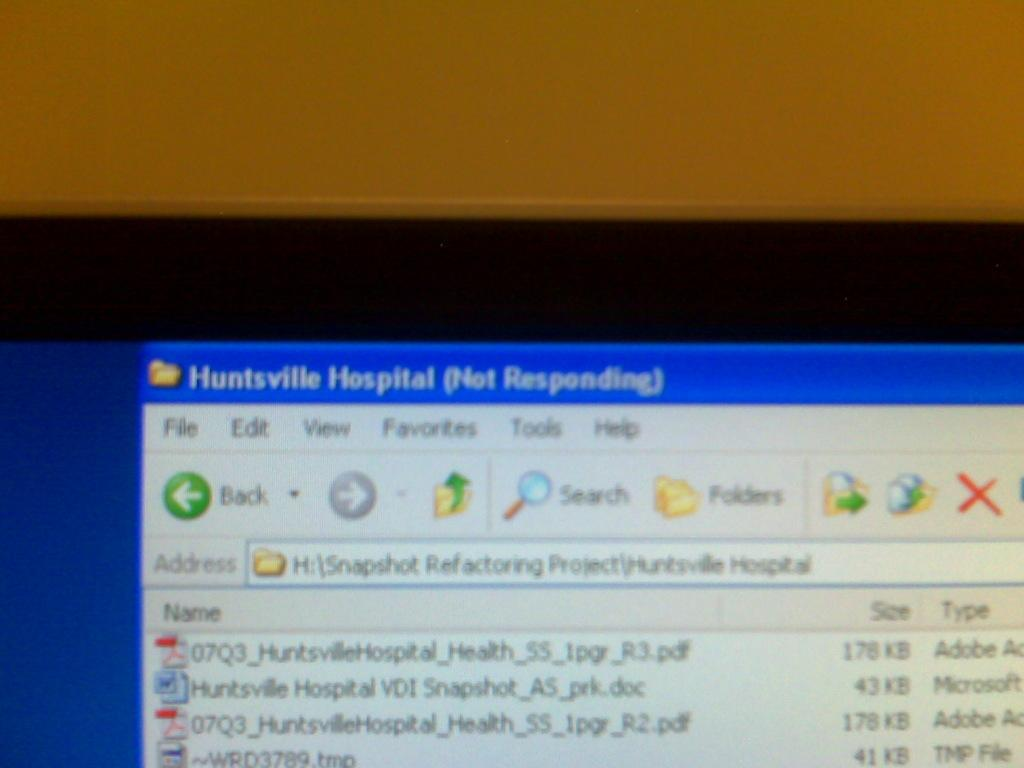<image>
Create a compact narrative representing the image presented. Computer screen opened up in file explorer that says Huntsville Hospital (Not Responding). 